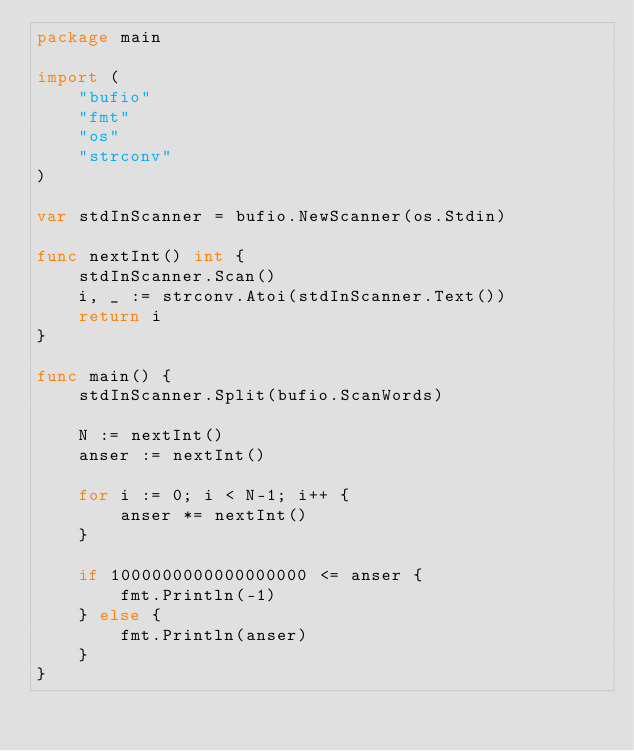<code> <loc_0><loc_0><loc_500><loc_500><_Go_>package main

import (
	"bufio"
	"fmt"
	"os"
	"strconv"
)

var stdInScanner = bufio.NewScanner(os.Stdin)

func nextInt() int {
	stdInScanner.Scan()
	i, _ := strconv.Atoi(stdInScanner.Text())
	return i
}

func main() {
	stdInScanner.Split(bufio.ScanWords)

	N := nextInt()
	anser := nextInt()

	for i := 0; i < N-1; i++ {
		anser *= nextInt()
	}

	if 1000000000000000000 <= anser {
		fmt.Println(-1)
	} else {
		fmt.Println(anser)
	}
}
</code> 